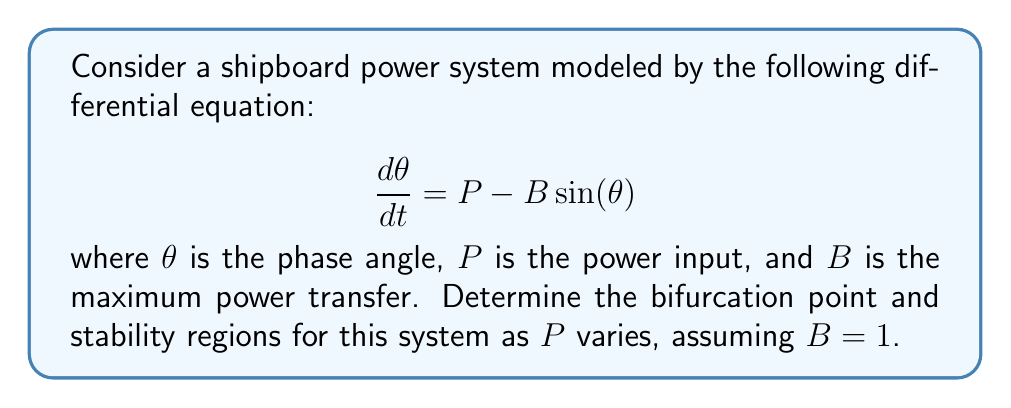Can you answer this question? 1) First, we need to find the equilibrium points of the system. These occur when $\frac{d\theta}{dt} = 0$:

   $$P - B\sin(\theta) = 0$$
   $$\sin(\theta) = \frac{P}{B}$$

2) Given $B = 1$, we have:
   $$\sin(\theta) = P$$

3) For this equation to have a solution, we must have $-1 \leq P \leq 1$. This gives us our first insight into the stability regions.

4) The equilibrium points are:
   $$\theta_1 = \arcsin(P)$$
   $$\theta_2 = \pi - \arcsin(P)$$

5) To determine stability, we need to evaluate the Jacobian at these points:
   $$J = \frac{\partial}{\partial\theta}(P - \sin(\theta)) = -\cos(\theta)$$

6) At $\theta_1$:
   $$J_1 = -\cos(\arcsin(P)) = -\sqrt{1-P^2}$$

7) At $\theta_2$:
   $$J_2 = -\cos(\pi - \arcsin(P)) = \sqrt{1-P^2}$$

8) The equilibrium point is stable if $J < 0$. Therefore:
   - $\theta_1$ is stable for $-1 < P < 1$
   - $\theta_2$ is unstable for $-1 < P < 1$

9) The bifurcation points occur when $J = 0$, which happens when $P = \pm 1$. These are saddle-node bifurcations.

10) The stability regions are:
    - For $P < -1$: No equilibrium points, system is unstable
    - For $-1 < P < 1$: Two equilibrium points, $\theta_1$ is stable, $\theta_2$ is unstable
    - For $P > 1$: No equilibrium points, system is unstable
Answer: Bifurcation points: $P = \pm 1$. Stability regions: Stable for $-1 < P < 1$ at $\theta_1 = \arcsin(P)$, unstable otherwise. 